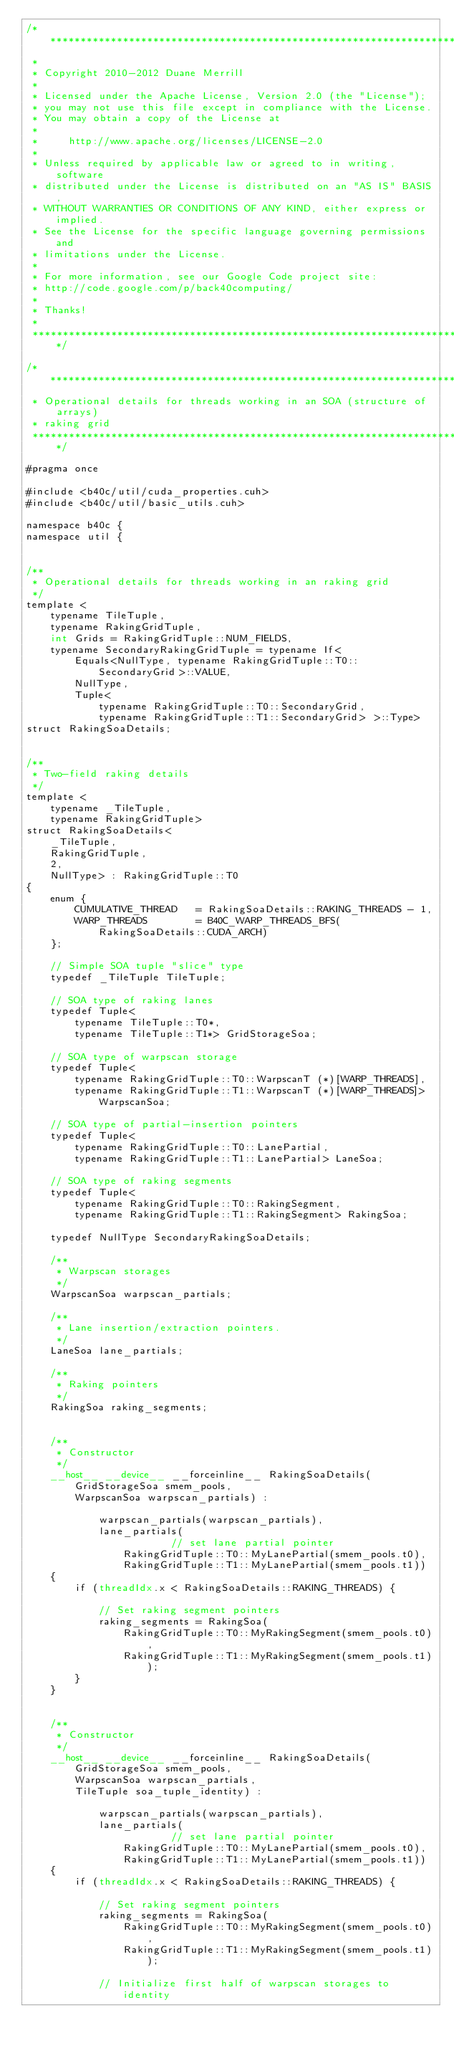Convert code to text. <code><loc_0><loc_0><loc_500><loc_500><_Cuda_>/******************************************************************************
 * 
 * Copyright 2010-2012 Duane Merrill
 * 
 * Licensed under the Apache License, Version 2.0 (the "License");
 * you may not use this file except in compliance with the License.
 * You may obtain a copy of the License at
 * 
 *     http://www.apache.org/licenses/LICENSE-2.0
 *
 * Unless required by applicable law or agreed to in writing, software
 * distributed under the License is distributed on an "AS IS" BASIS,
 * WITHOUT WARRANTIES OR CONDITIONS OF ANY KIND, either express or implied.
 * See the License for the specific language governing permissions and
 * limitations under the License. 
 * 
 * For more information, see our Google Code project site: 
 * http://code.google.com/p/back40computing/
 * 
 * Thanks!
 * 
 ******************************************************************************/

/******************************************************************************
 * Operational details for threads working in an SOA (structure of arrays)
 * raking grid
 ******************************************************************************/

#pragma once

#include <b40c/util/cuda_properties.cuh>
#include <b40c/util/basic_utils.cuh>

namespace b40c {
namespace util {


/**
 * Operational details for threads working in an raking grid
 */
template <
	typename TileTuple,
	typename RakingGridTuple,
	int Grids = RakingGridTuple::NUM_FIELDS,
	typename SecondaryRakingGridTuple = typename If<
		Equals<NullType, typename RakingGridTuple::T0::SecondaryGrid>::VALUE,
		NullType,
		Tuple<
			typename RakingGridTuple::T0::SecondaryGrid,
			typename RakingGridTuple::T1::SecondaryGrid> >::Type>
struct RakingSoaDetails;


/**
 * Two-field raking details
 */
template <
	typename _TileTuple,
	typename RakingGridTuple>
struct RakingSoaDetails<
	_TileTuple,
	RakingGridTuple,
	2,
	NullType> : RakingGridTuple::T0
{
	enum {
		CUMULATIVE_THREAD 	= RakingSoaDetails::RAKING_THREADS - 1,
		WARP_THREADS 		= B40C_WARP_THREADS_BFS(RakingSoaDetails::CUDA_ARCH)
	};

	// Simple SOA tuple "slice" type
	typedef _TileTuple TileTuple;

	// SOA type of raking lanes
	typedef Tuple<
		typename TileTuple::T0*,
		typename TileTuple::T1*> GridStorageSoa;

	// SOA type of warpscan storage
	typedef Tuple<
		typename RakingGridTuple::T0::WarpscanT (*)[WARP_THREADS],
		typename RakingGridTuple::T1::WarpscanT (*)[WARP_THREADS]> WarpscanSoa;

	// SOA type of partial-insertion pointers
	typedef Tuple<
		typename RakingGridTuple::T0::LanePartial,
		typename RakingGridTuple::T1::LanePartial> LaneSoa;

	// SOA type of raking segments
	typedef Tuple<
		typename RakingGridTuple::T0::RakingSegment,
		typename RakingGridTuple::T1::RakingSegment> RakingSoa;

	typedef NullType SecondaryRakingSoaDetails;

	/**
	 * Warpscan storages
	 */
	WarpscanSoa warpscan_partials;

	/**
	 * Lane insertion/extraction pointers.
	 */
	LaneSoa lane_partials;

	/**
	 * Raking pointers
	 */
	RakingSoa raking_segments;


	/**
	 * Constructor
	 */
	__host__ __device__ __forceinline__ RakingSoaDetails(
		GridStorageSoa smem_pools,
		WarpscanSoa warpscan_partials) :

			warpscan_partials(warpscan_partials),
			lane_partials(												// set lane partial pointer
				RakingGridTuple::T0::MyLanePartial(smem_pools.t0),
				RakingGridTuple::T1::MyLanePartial(smem_pools.t1))
	{
		if (threadIdx.x < RakingSoaDetails::RAKING_THREADS) {

			// Set raking segment pointers
			raking_segments = RakingSoa(
				RakingGridTuple::T0::MyRakingSegment(smem_pools.t0),
				RakingGridTuple::T1::MyRakingSegment(smem_pools.t1));
		}
	}


	/**
	 * Constructor
	 */
	__host__ __device__ __forceinline__ RakingSoaDetails(
		GridStorageSoa smem_pools,
		WarpscanSoa warpscan_partials,
		TileTuple soa_tuple_identity) :

			warpscan_partials(warpscan_partials),
			lane_partials(												// set lane partial pointer
				RakingGridTuple::T0::MyLanePartial(smem_pools.t0),
				RakingGridTuple::T1::MyLanePartial(smem_pools.t1))
	{
		if (threadIdx.x < RakingSoaDetails::RAKING_THREADS) {

			// Set raking segment pointers
			raking_segments = RakingSoa(
				RakingGridTuple::T0::MyRakingSegment(smem_pools.t0),
				RakingGridTuple::T1::MyRakingSegment(smem_pools.t1));

			// Initialize first half of warpscan storages to identity</code> 